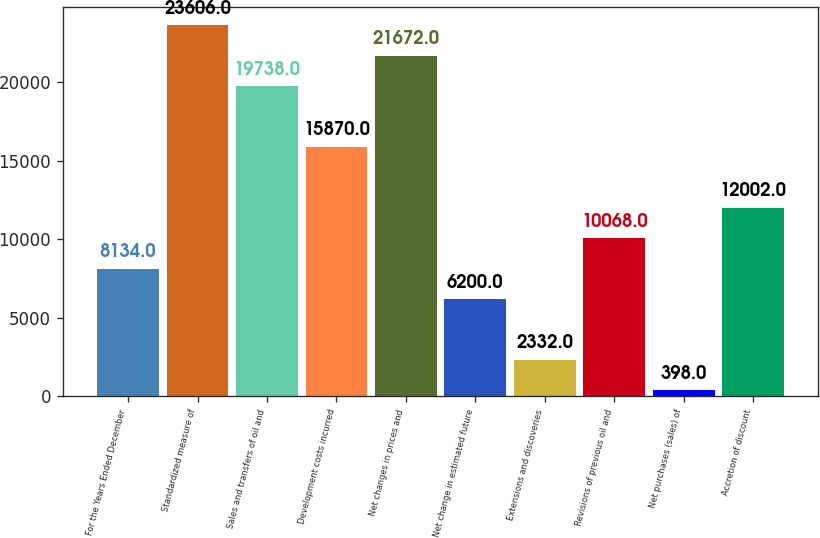<chart> <loc_0><loc_0><loc_500><loc_500><bar_chart><fcel>For the Years Ended December<fcel>Standardized measure of<fcel>Sales and transfers of oil and<fcel>Development costs incurred<fcel>Net changes in prices and<fcel>Net change in estimated future<fcel>Extensions and discoveries<fcel>Revisions of previous oil and<fcel>Net purchases (sales) of<fcel>Accretion of discount<nl><fcel>8134<fcel>23606<fcel>19738<fcel>15870<fcel>21672<fcel>6200<fcel>2332<fcel>10068<fcel>398<fcel>12002<nl></chart> 